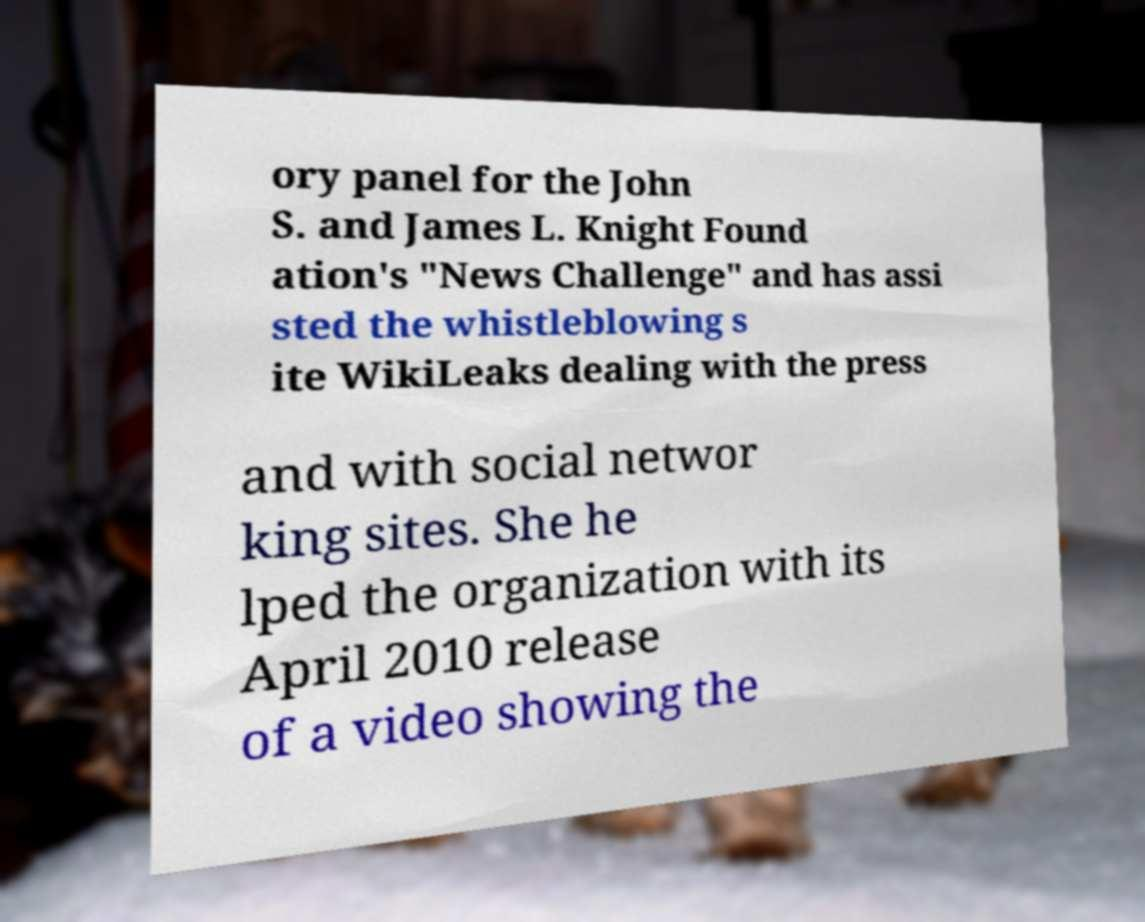For documentation purposes, I need the text within this image transcribed. Could you provide that? ory panel for the John S. and James L. Knight Found ation's "News Challenge" and has assi sted the whistleblowing s ite WikiLeaks dealing with the press and with social networ king sites. She he lped the organization with its April 2010 release of a video showing the 